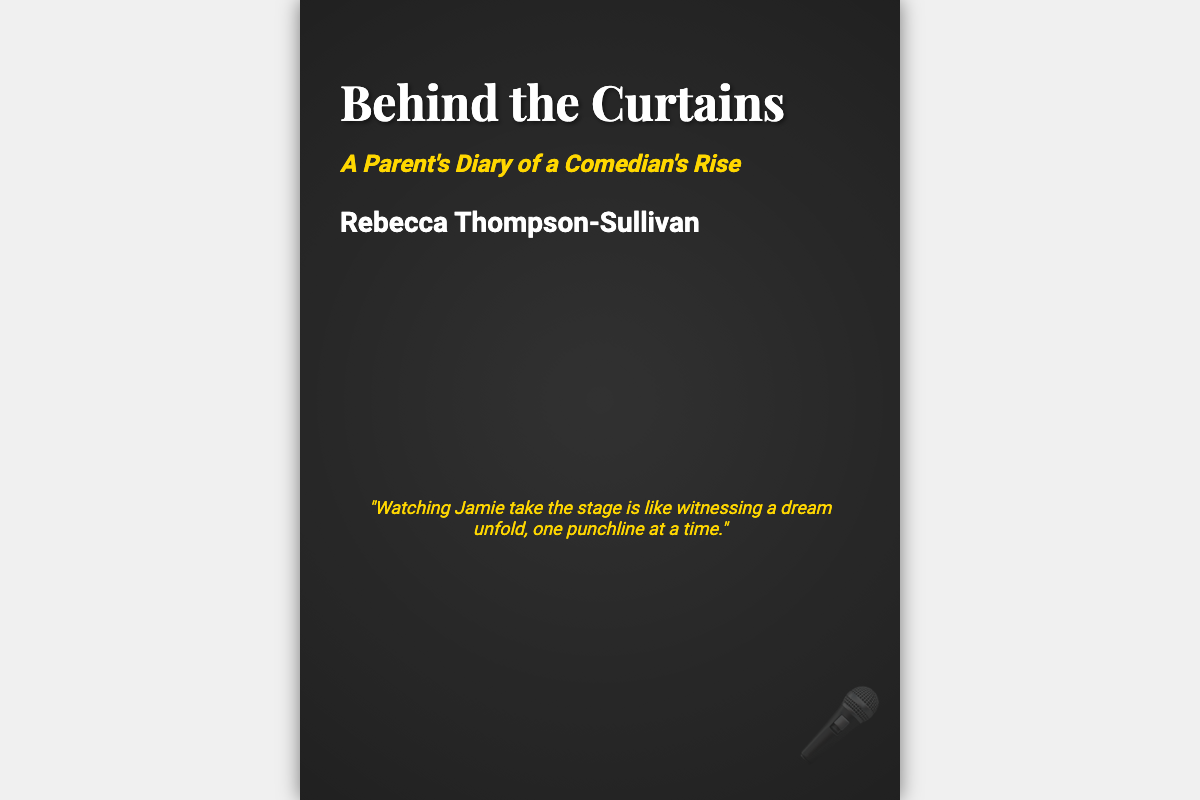What is the title of the book? The title of the book is prominently displayed at the top of the cover.
Answer: Behind the Curtains Who is the author of the book? The author's name is noted near the bottom of the cover.
Answer: Rebecca Thompson-Sullivan What is the subtitle of the book? The subtitle provides further information about the book's content and is located beneath the title.
Answer: A Parent's Diary of a Comedian's Rise What quote is featured on the cover? The quote is found in the center of the cover and reflects the author's thoughts.
Answer: "Watching Jamie take the stage is like witnessing a dream unfold, one punchline at a time." What is the color scheme of the book cover? The cover uses contrasting colors with specific hues for the background and text.
Answer: Black and gold What does the tagline suggest about the book? The tagline implies a deeper narrative within the comedic journey represented in the book.
Answer: There's more to the laughs than meets the eye How does the author feel about Jamie's performances? The quote indicates the author's perspective on Jamie's work in comedy.
Answer: Positive What symbol is displayed at the bottom right of the cover? The symbol relates to the theme of comedy and is positioned at the bottom of the cover.
Answer: Microphone 